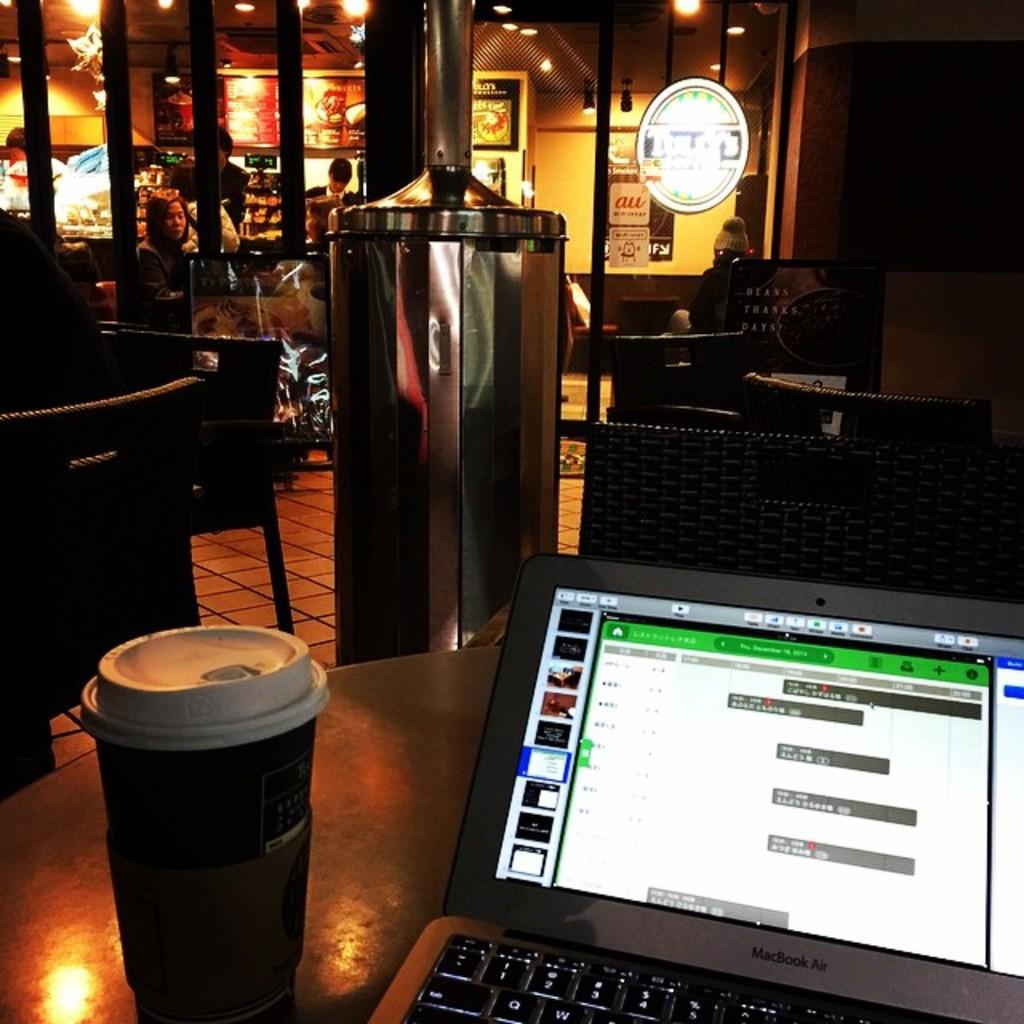What kind of laptop is sitting on the table?
Make the answer very short. Macbook air. What is the highest number on the keyboard that you can see?
Your answer should be very brief. 5. 